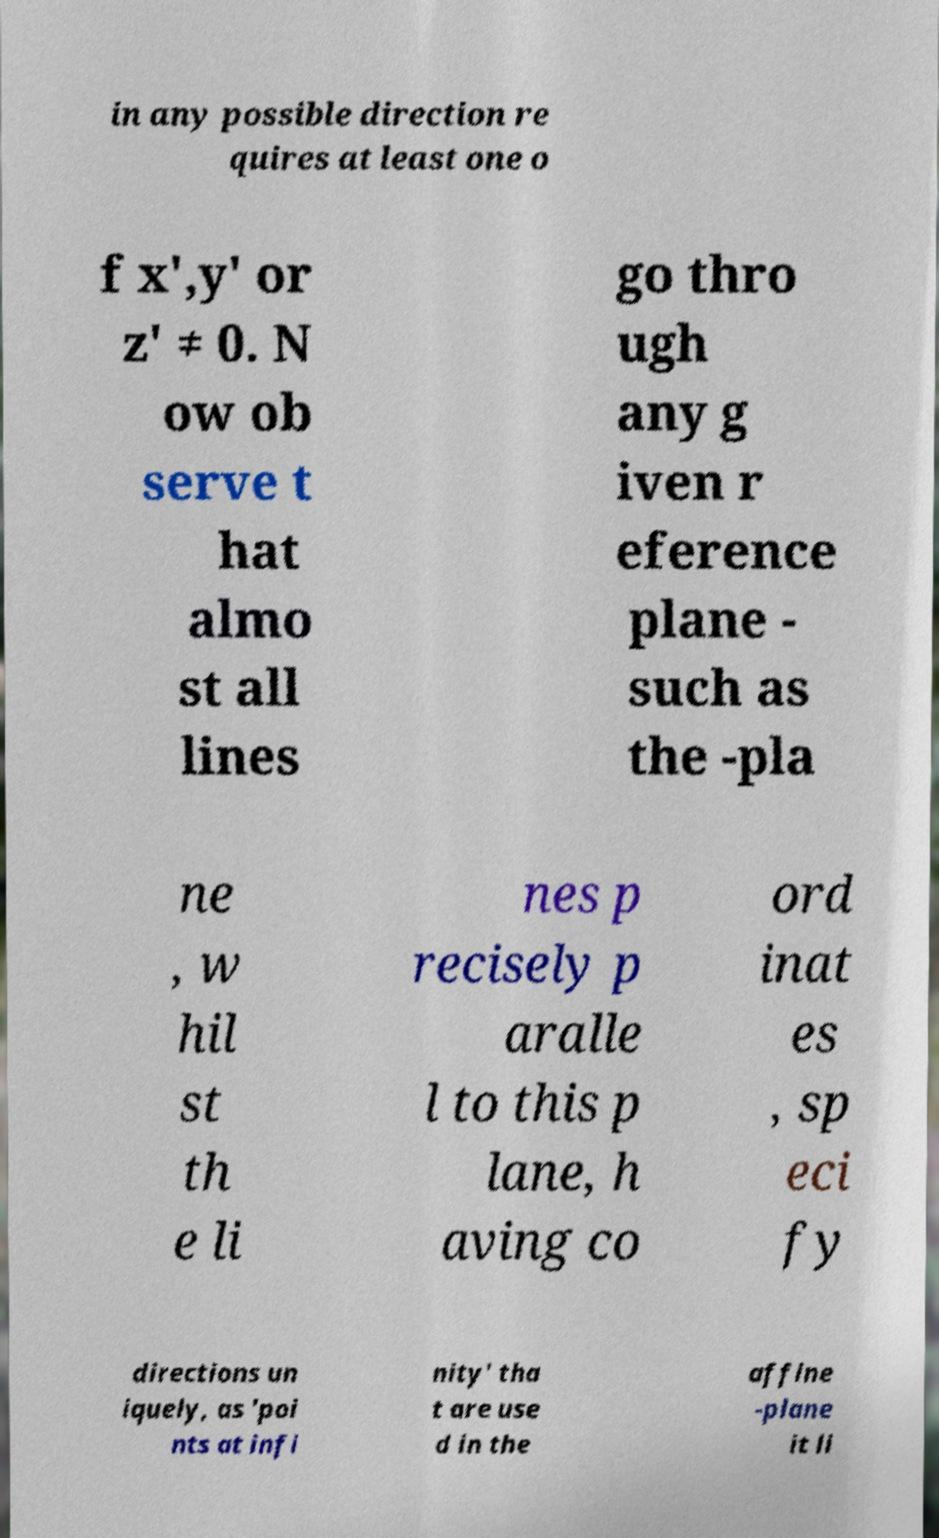Please read and relay the text visible in this image. What does it say? in any possible direction re quires at least one o f x',y' or z' ≠ 0. N ow ob serve t hat almo st all lines go thro ugh any g iven r eference plane - such as the -pla ne , w hil st th e li nes p recisely p aralle l to this p lane, h aving co ord inat es , sp eci fy directions un iquely, as 'poi nts at infi nity' tha t are use d in the affine -plane it li 